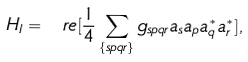Convert formula to latex. <formula><loc_0><loc_0><loc_500><loc_500>H _ { I } = \ r e [ \frac { 1 } { 4 } \sum _ { \{ s p q r \} } g _ { s p q r } a _ { s } a _ { p } a _ { q } ^ { * } a _ { r } ^ { * } ] ,</formula> 